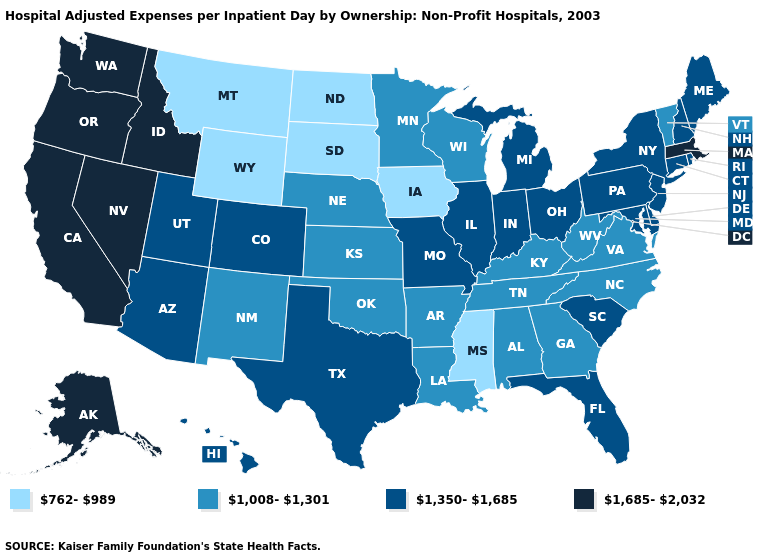What is the value of Arizona?
Keep it brief. 1,350-1,685. Name the states that have a value in the range 1,685-2,032?
Short answer required. Alaska, California, Idaho, Massachusetts, Nevada, Oregon, Washington. Name the states that have a value in the range 1,350-1,685?
Write a very short answer. Arizona, Colorado, Connecticut, Delaware, Florida, Hawaii, Illinois, Indiana, Maine, Maryland, Michigan, Missouri, New Hampshire, New Jersey, New York, Ohio, Pennsylvania, Rhode Island, South Carolina, Texas, Utah. What is the value of Wyoming?
Answer briefly. 762-989. What is the value of Alaska?
Keep it brief. 1,685-2,032. Does the first symbol in the legend represent the smallest category?
Be succinct. Yes. Name the states that have a value in the range 1,008-1,301?
Be succinct. Alabama, Arkansas, Georgia, Kansas, Kentucky, Louisiana, Minnesota, Nebraska, New Mexico, North Carolina, Oklahoma, Tennessee, Vermont, Virginia, West Virginia, Wisconsin. Among the states that border Minnesota , which have the lowest value?
Answer briefly. Iowa, North Dakota, South Dakota. Does Maine have the same value as Alaska?
Short answer required. No. What is the lowest value in the Northeast?
Quick response, please. 1,008-1,301. Does Maryland have the highest value in the South?
Concise answer only. Yes. Does the map have missing data?
Concise answer only. No. Does the map have missing data?
Concise answer only. No. Name the states that have a value in the range 762-989?
Be succinct. Iowa, Mississippi, Montana, North Dakota, South Dakota, Wyoming. What is the highest value in states that border Wisconsin?
Short answer required. 1,350-1,685. 